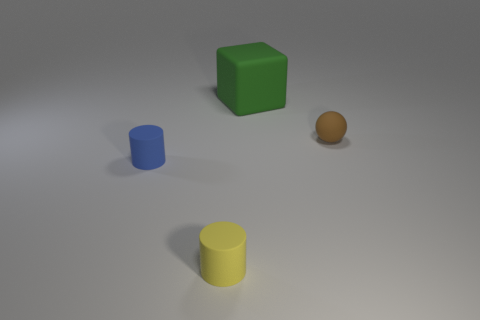Are there any tiny red cylinders?
Ensure brevity in your answer.  No. Is the number of yellow things to the left of the brown matte ball greater than the number of small yellow things to the left of the block?
Give a very brief answer. No. What material is the tiny blue object that is the same shape as the yellow rubber thing?
Offer a very short reply. Rubber. Are there any other things that have the same size as the green object?
Ensure brevity in your answer.  No. The yellow matte object has what shape?
Provide a short and direct response. Cylinder. Are there more brown things in front of the small yellow thing than yellow matte cylinders?
Provide a short and direct response. No. What is the shape of the tiny thing on the left side of the small yellow thing?
Keep it short and to the point. Cylinder. How many other objects are the same shape as the brown object?
Offer a very short reply. 0. Is the tiny cylinder behind the tiny yellow cylinder made of the same material as the tiny ball?
Ensure brevity in your answer.  Yes. Is the number of tiny brown things left of the small yellow rubber object the same as the number of tiny rubber things in front of the green cube?
Keep it short and to the point. No. 